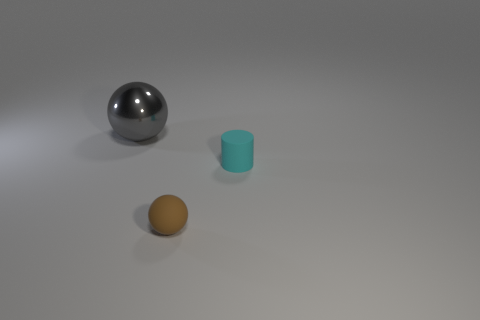Add 3 big gray balls. How many objects exist? 6 Subtract all brown balls. How many balls are left? 1 Subtract all spheres. How many objects are left? 1 Subtract all green balls. Subtract all blue cubes. How many balls are left? 2 Subtract all green cubes. How many gray spheres are left? 1 Subtract all small blue matte things. Subtract all small cyan rubber cylinders. How many objects are left? 2 Add 1 small matte cylinders. How many small matte cylinders are left? 2 Add 3 tiny cyan cylinders. How many tiny cyan cylinders exist? 4 Subtract 1 cyan cylinders. How many objects are left? 2 